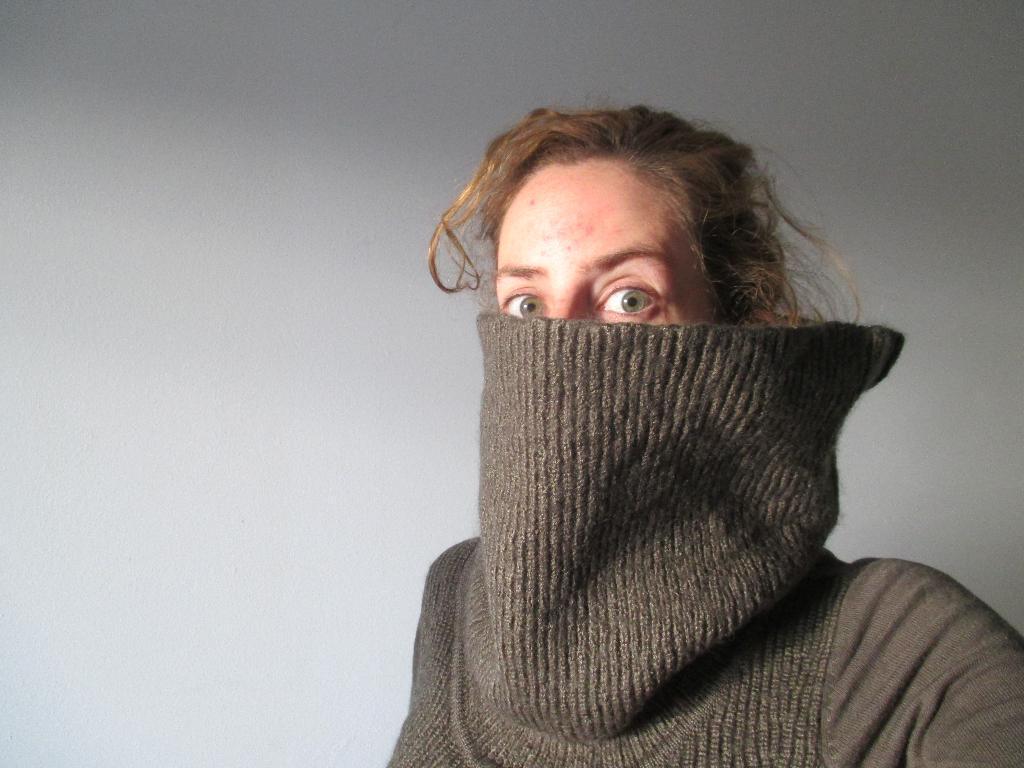How would you summarize this image in a sentence or two? The picture consists of a person in grey jacket. In the background it is wall painted white. 